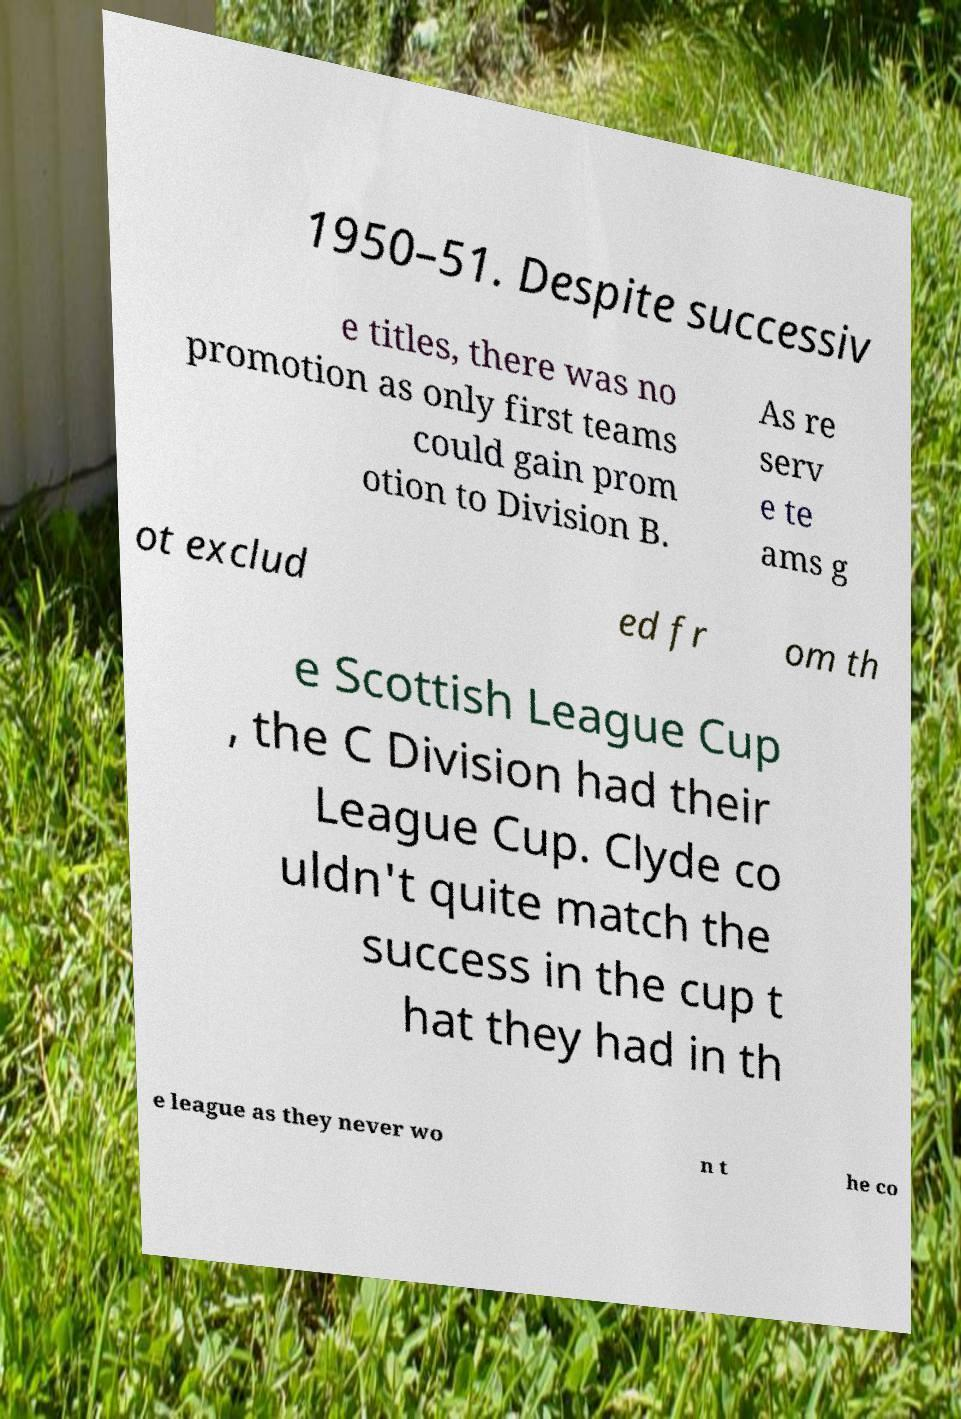Could you assist in decoding the text presented in this image and type it out clearly? 1950–51. Despite successiv e titles, there was no promotion as only first teams could gain prom otion to Division B. As re serv e te ams g ot exclud ed fr om th e Scottish League Cup , the C Division had their League Cup. Clyde co uldn't quite match the success in the cup t hat they had in th e league as they never wo n t he co 